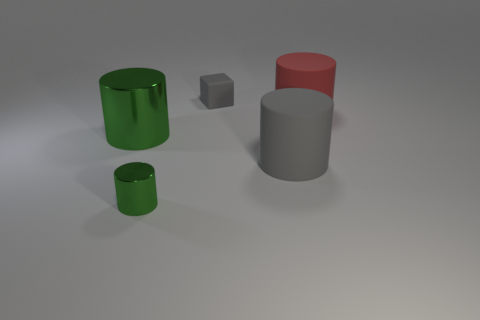How many green cylinders must be subtracted to get 1 green cylinders? 1 Subtract all large metal cylinders. How many cylinders are left? 3 Add 3 cylinders. How many objects exist? 8 Subtract all gray balls. How many green cylinders are left? 2 Subtract 3 cylinders. How many cylinders are left? 1 Subtract all large green metal objects. Subtract all gray matte cylinders. How many objects are left? 3 Add 2 small green metal cylinders. How many small green metal cylinders are left? 3 Add 2 tiny cylinders. How many tiny cylinders exist? 3 Subtract all gray cylinders. How many cylinders are left? 3 Subtract 0 red balls. How many objects are left? 5 